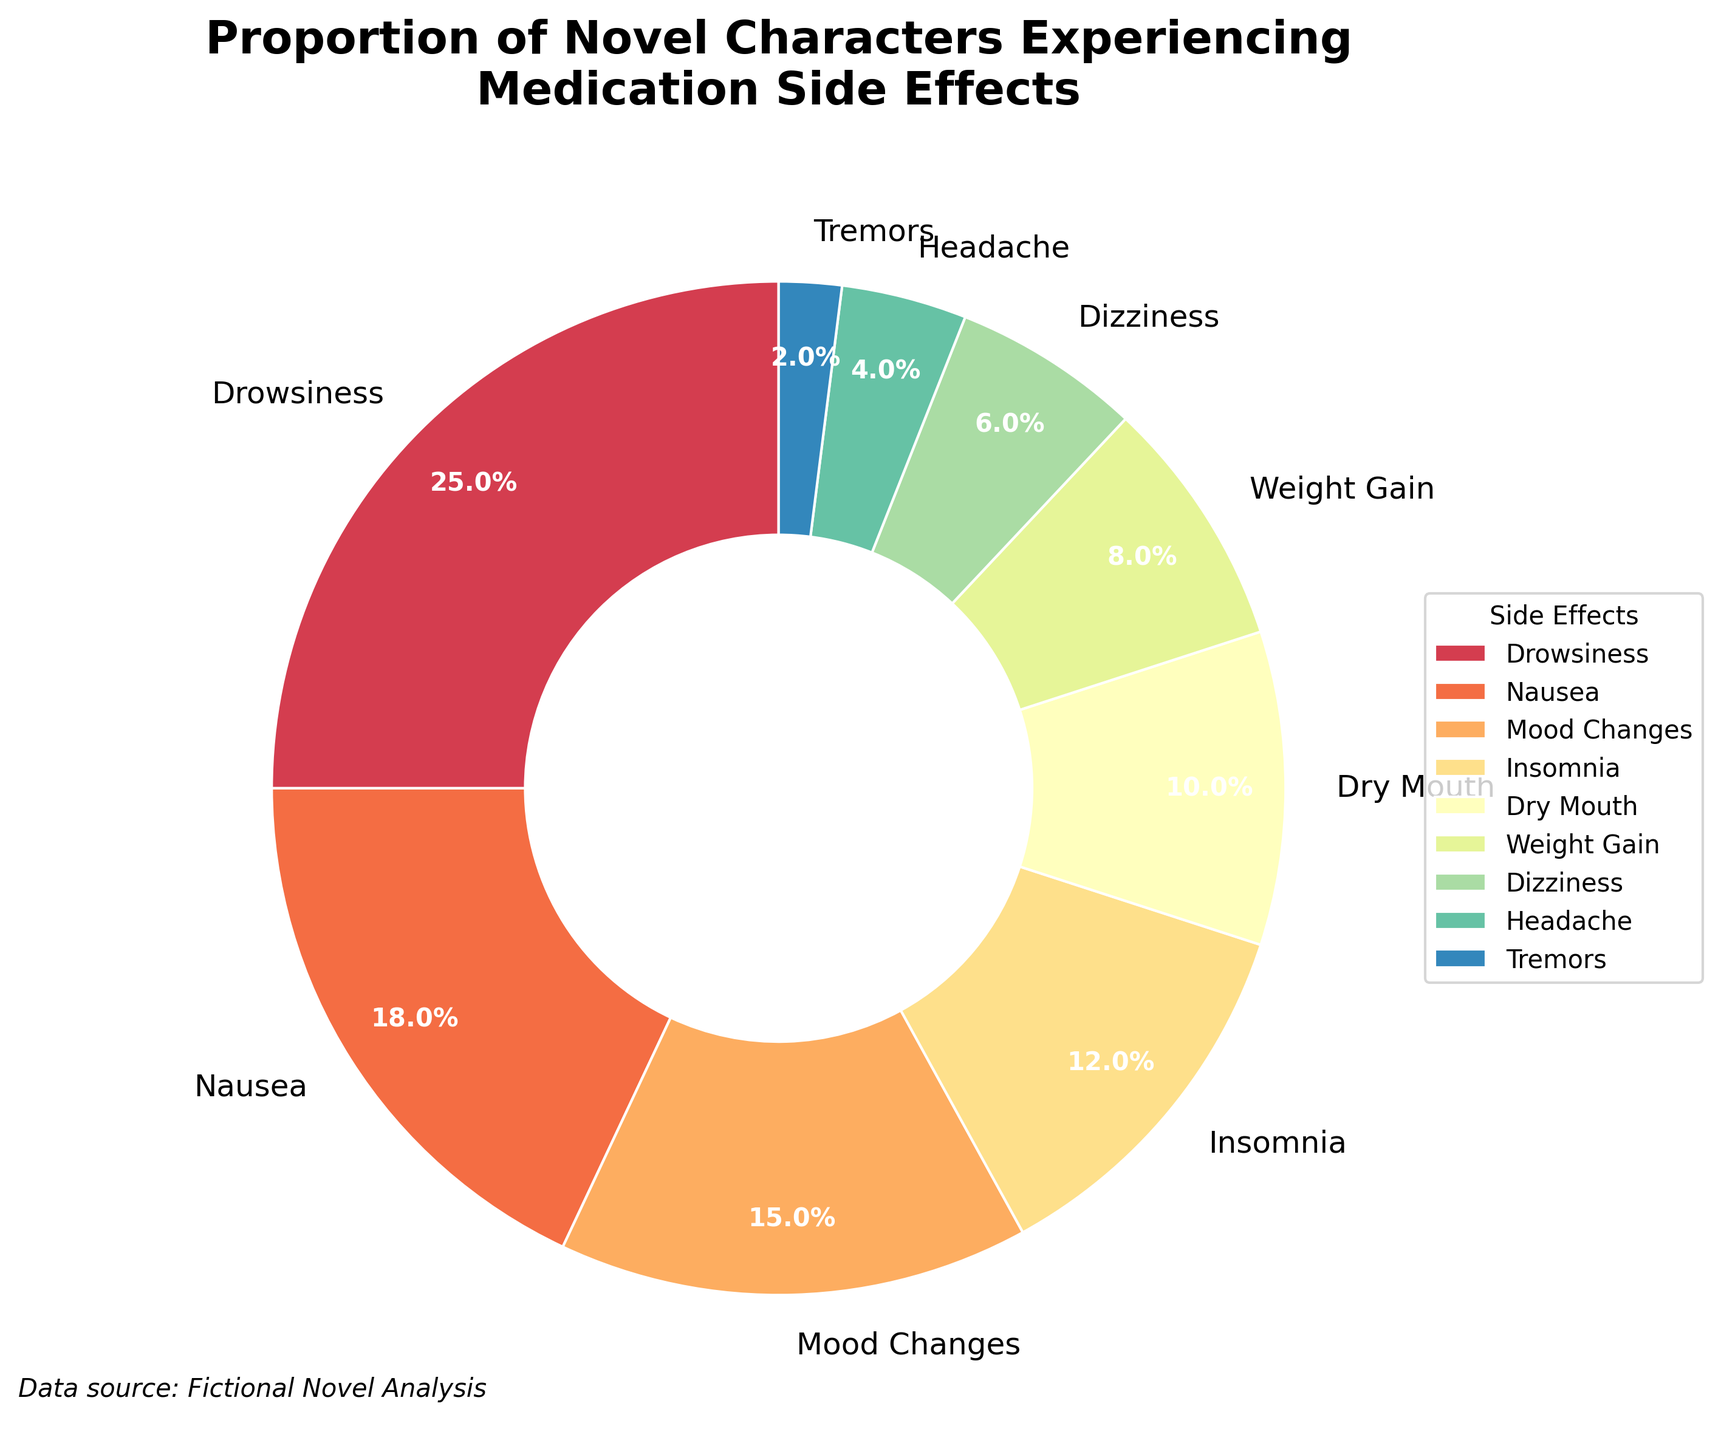What is the percentage of characters experiencing drowsiness? The proportion for drowsiness is directly labeled in the pie chart section for 'Drowsiness'.
Answer: 25% Which side effect has the lowest percentage of occurrence among the characters? By examining the smallest segment in the pie chart, labeled 'Tremors', we can see it has the lowest percentage.
Answer: Tremors Are there more characters experiencing nausea or insomnia? Comparing the segments labeled 'Nausea' and 'Insomnia', the 'Nausea' segment is larger.
Answer: Nausea What is the combined percentage of characters experiencing mood changes and weight gain? Add the percentages for mood changes (15%) and weight gain (8%) together: 15% + 8% = 23%.
Answer: 23% How much higher is the percentage of characters experiencing drowsiness compared to dizziness? Subtract the percentage of dizziness (6%) from drowsiness (25%): 25% - 6% = 19%.
Answer: 19% Which segment is larger: dry mouth or headache? By comparing the segments, 'Dry Mouth' is larger than 'Headache'.
Answer: Dry Mouth What is the average percentage of characters experiencing side effects related to drowsiness, insomnia, and dry mouth? Add percentages for drowsiness (25%), insomnia (12%), and dry mouth (10%), then divide by 3: (25% + 12% + 10%) / 3 ≈ 15.7%.
Answer: 15.7% What is the difference in percentage between characters experiencing insomnia and those experiencing mood changes? Subtract the percentage for mood changes (15%) from insomnia (12%): 15% - 12% = 3%.
Answer: 3% How many side effects have a percentage of 10% or higher? Identify and count all segments equal to or greater than 10%. They are: Drowsiness, Nausea, Mood Changes, Insomnia, and Dry Mouth.
Answer: 5 What is the total percentage of characters experiencing dizziness, headache, and tremors combined? Add the percentages for dizziness (6%), headache (4%), and tremors (2%): 6% + 4% + 2% = 12%.
Answer: 12% 